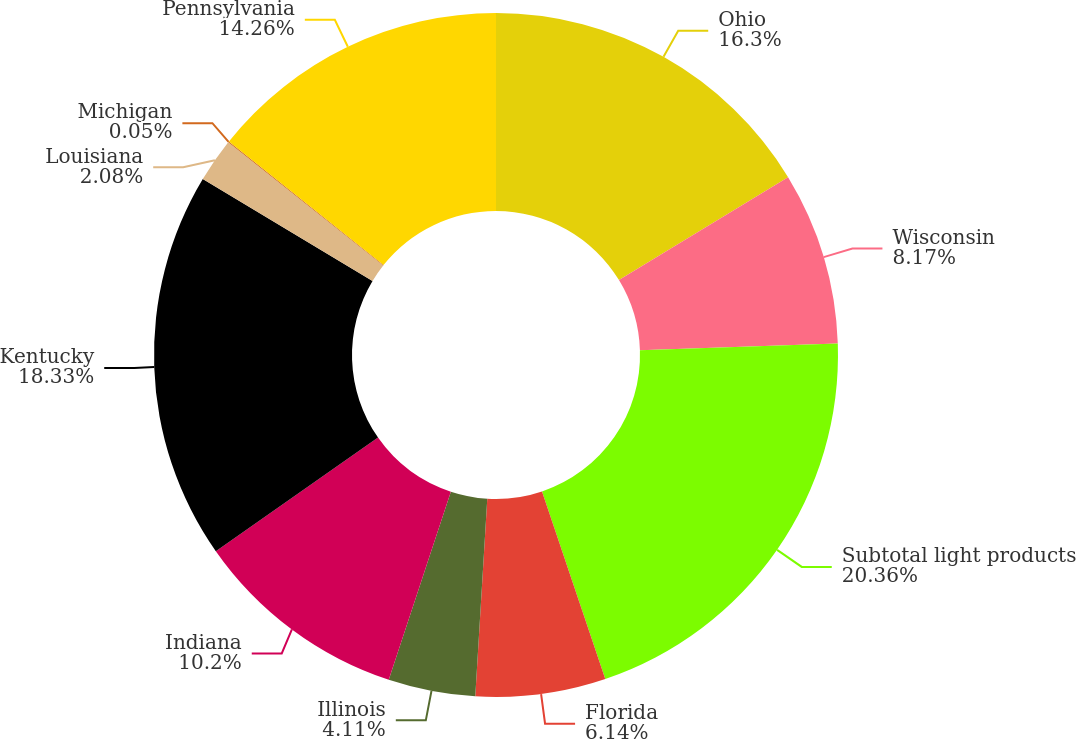Convert chart. <chart><loc_0><loc_0><loc_500><loc_500><pie_chart><fcel>Ohio<fcel>Wisconsin<fcel>Subtotal light products<fcel>Florida<fcel>Illinois<fcel>Indiana<fcel>Kentucky<fcel>Louisiana<fcel>Michigan<fcel>Pennsylvania<nl><fcel>16.29%<fcel>8.17%<fcel>20.35%<fcel>6.14%<fcel>4.11%<fcel>10.2%<fcel>18.32%<fcel>2.08%<fcel>0.05%<fcel>14.26%<nl></chart> 